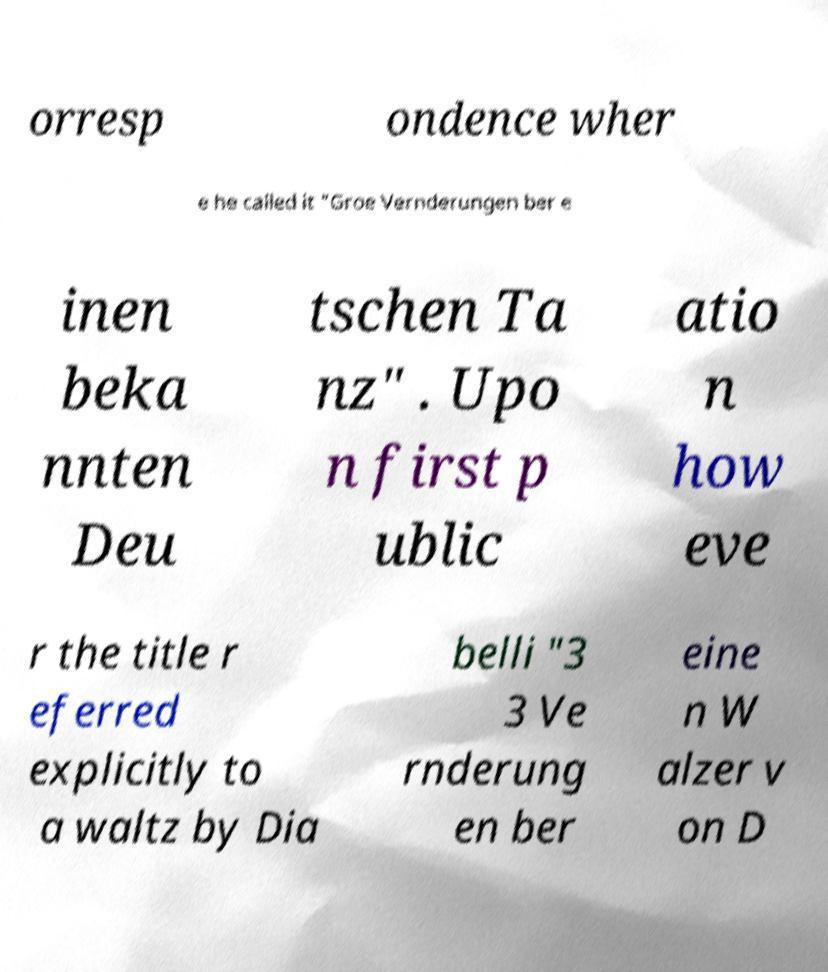There's text embedded in this image that I need extracted. Can you transcribe it verbatim? orresp ondence wher e he called it "Groe Vernderungen ber e inen beka nnten Deu tschen Ta nz" . Upo n first p ublic atio n how eve r the title r eferred explicitly to a waltz by Dia belli "3 3 Ve rnderung en ber eine n W alzer v on D 